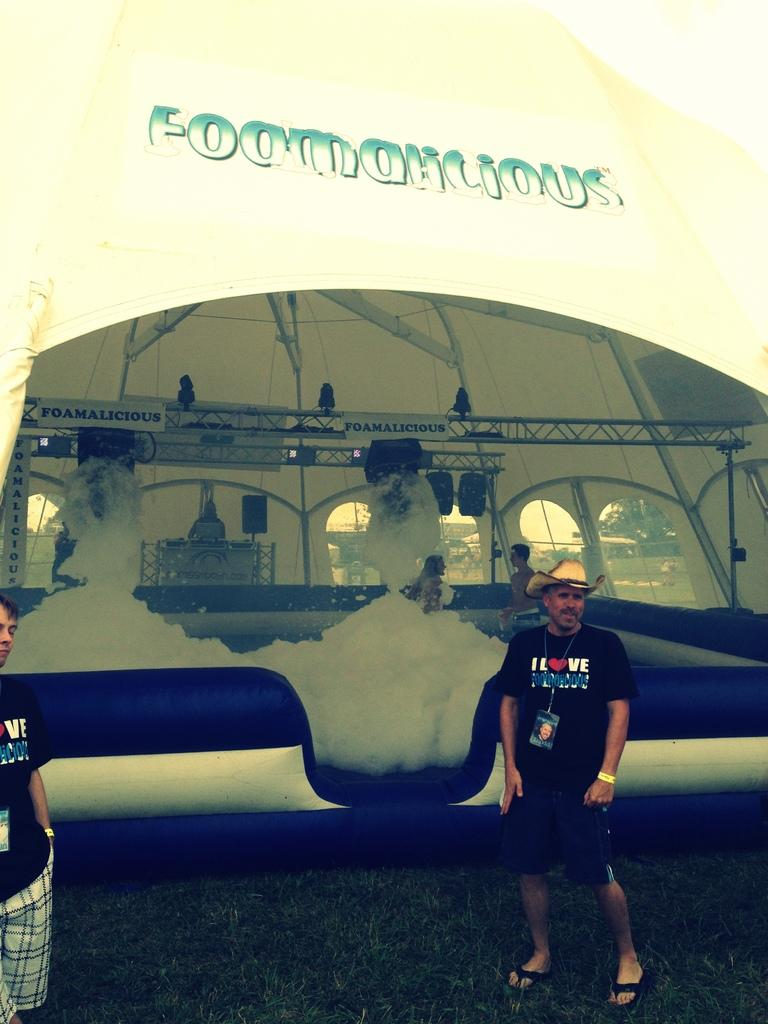What can be seen in the image? There is a group of people in the image. Can you describe the man on the right side of the image? The man is wearing a cap. What can be seen in the background of the image? There is foam, metal rods, a tent, and trees in the background of the image. What type of instrument is the man playing in the image? There is no instrument present in the image, and the man is not playing any instrument. What is the man feeling ashamed about in the image? There is no indication of shame or any specific emotion in the image; the man is simply wearing a cap and standing with the group of people. 